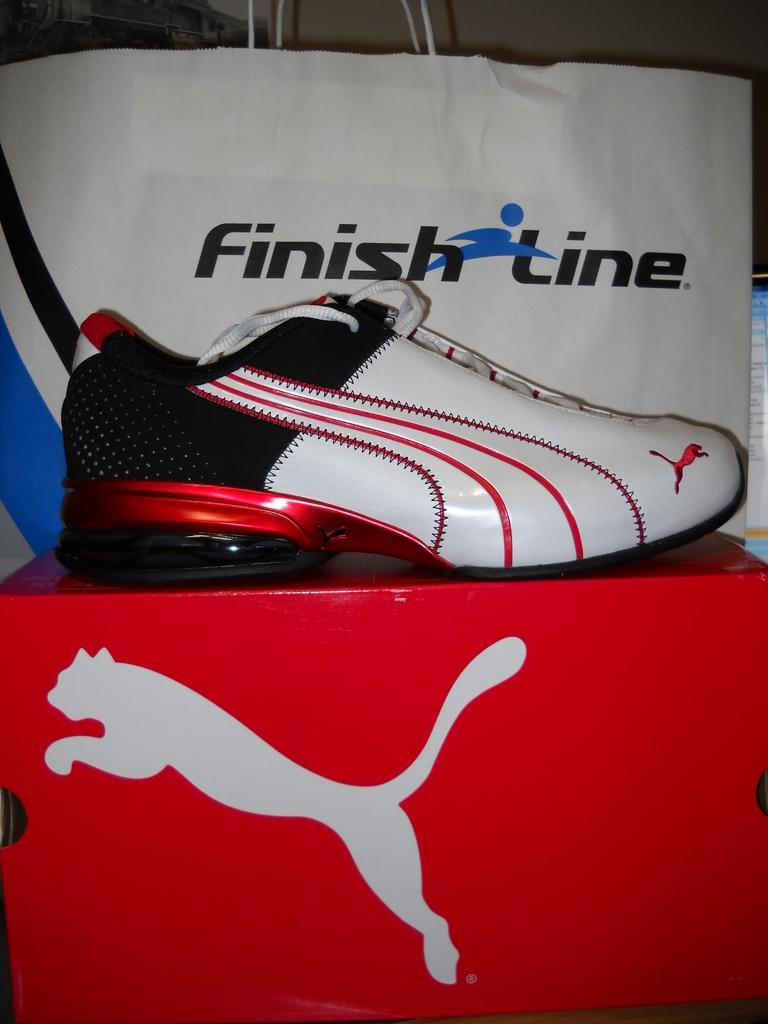What object can be seen in the image that people wear on their feet? There is a shoe in the image that people wear on their feet. What object in the image might be used for storing or containing other items? There is a box in the image that might be used for storing or containing other items. What object in the image is covering or protecting something else? There is a cover in the image that is covering or protecting something else. What type of loaf is being baked in the image? There is no loaf present in the image; it only features a shoe, a box, and a cover. What direction is the shoe pointing in the image? The shoe's direction is not relevant to the image, as it is stationary and not actively pointing in any particular direction. 